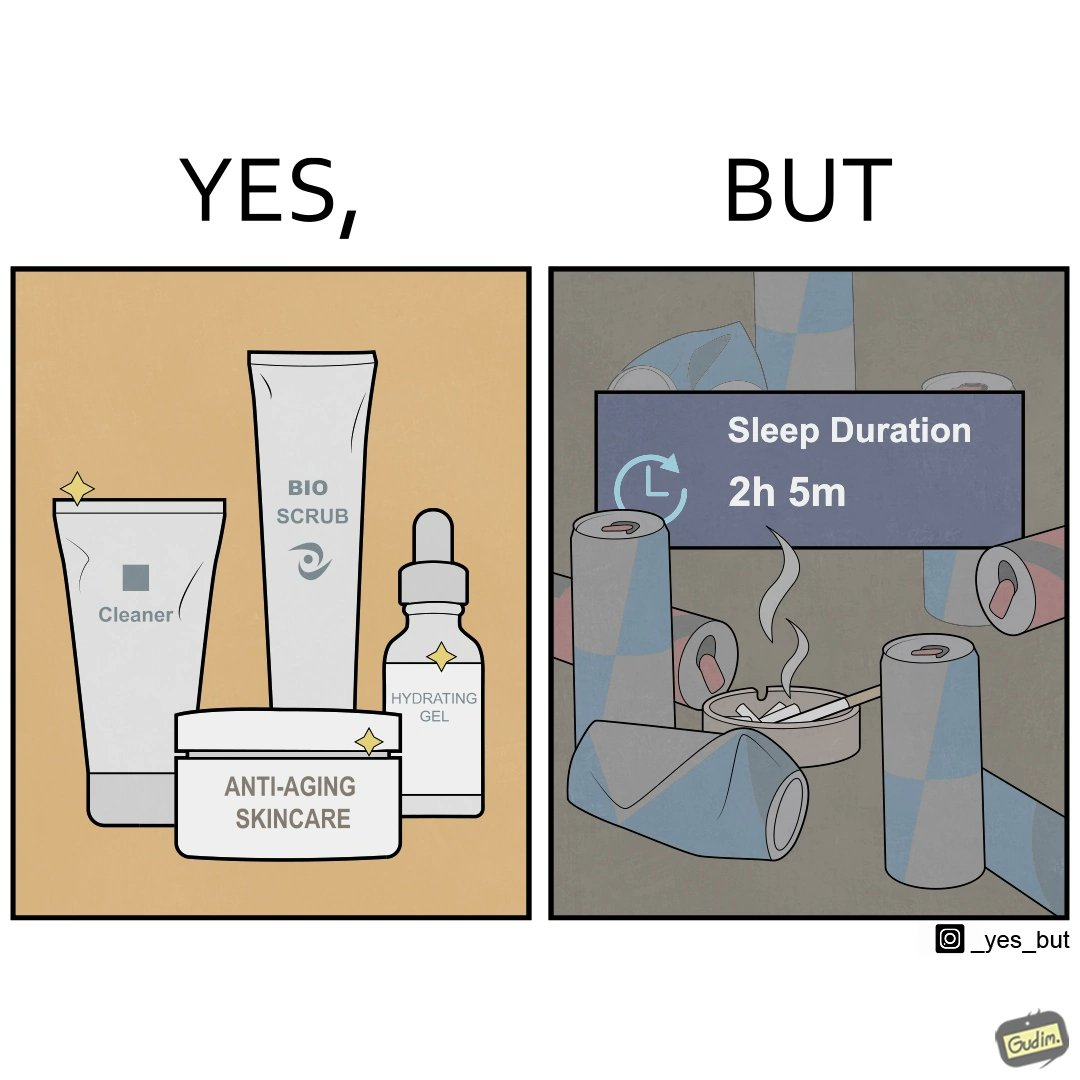What is the satirical meaning behind this image? This image is ironic as on the one hand, the presumed person is into skincare and wants to do the best for their skin, which is good, but on the other hand, they are involved in unhealthy habits that will damage their skin like smoking, caffeine and inadequate sleep. 